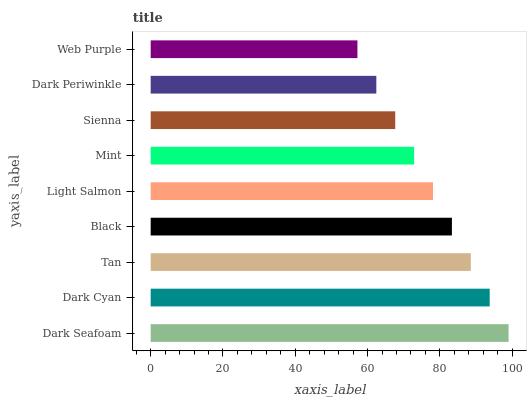Is Web Purple the minimum?
Answer yes or no. Yes. Is Dark Seafoam the maximum?
Answer yes or no. Yes. Is Dark Cyan the minimum?
Answer yes or no. No. Is Dark Cyan the maximum?
Answer yes or no. No. Is Dark Seafoam greater than Dark Cyan?
Answer yes or no. Yes. Is Dark Cyan less than Dark Seafoam?
Answer yes or no. Yes. Is Dark Cyan greater than Dark Seafoam?
Answer yes or no. No. Is Dark Seafoam less than Dark Cyan?
Answer yes or no. No. Is Light Salmon the high median?
Answer yes or no. Yes. Is Light Salmon the low median?
Answer yes or no. Yes. Is Dark Seafoam the high median?
Answer yes or no. No. Is Black the low median?
Answer yes or no. No. 